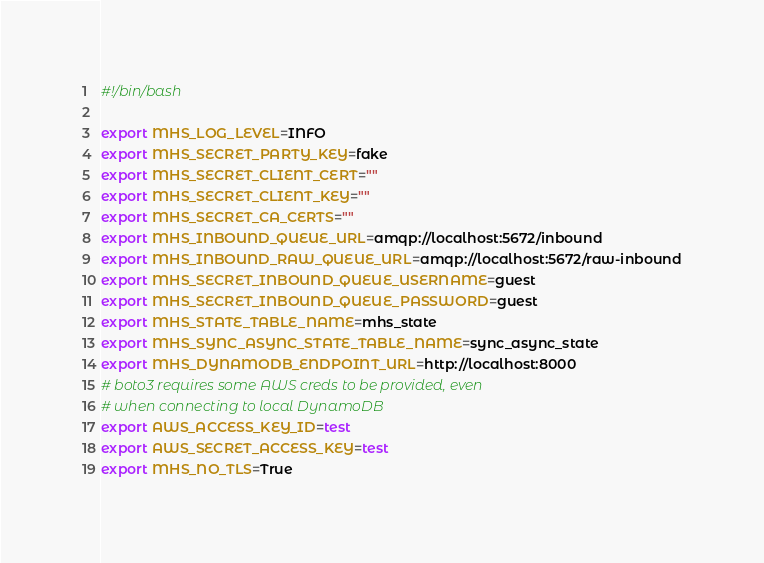Convert code to text. <code><loc_0><loc_0><loc_500><loc_500><_Bash_>#!/bin/bash

export MHS_LOG_LEVEL=INFO
export MHS_SECRET_PARTY_KEY=fake
export MHS_SECRET_CLIENT_CERT=""
export MHS_SECRET_CLIENT_KEY=""
export MHS_SECRET_CA_CERTS=""
export MHS_INBOUND_QUEUE_URL=amqp://localhost:5672/inbound
export MHS_INBOUND_RAW_QUEUE_URL=amqp://localhost:5672/raw-inbound
export MHS_SECRET_INBOUND_QUEUE_USERNAME=guest
export MHS_SECRET_INBOUND_QUEUE_PASSWORD=guest
export MHS_STATE_TABLE_NAME=mhs_state
export MHS_SYNC_ASYNC_STATE_TABLE_NAME=sync_async_state
export MHS_DYNAMODB_ENDPOINT_URL=http://localhost:8000
# boto3 requires some AWS creds to be provided, even
# when connecting to local DynamoDB
export AWS_ACCESS_KEY_ID=test
export AWS_SECRET_ACCESS_KEY=test
export MHS_NO_TLS=True
</code> 